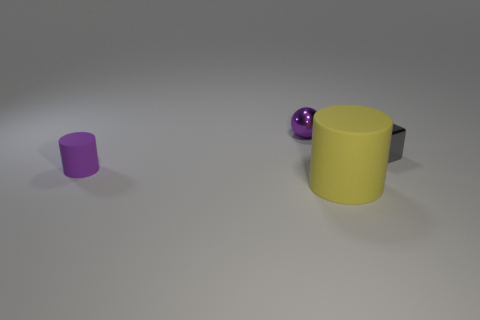What shape is the shiny object that is the same color as the tiny rubber cylinder?
Provide a short and direct response. Sphere. What is the size of the cylinder that is to the right of the ball that is on the left side of the large matte thing?
Provide a short and direct response. Large. There is a metallic ball that is the same color as the tiny rubber object; what size is it?
Give a very brief answer. Small. Is the gray thing the same size as the yellow thing?
Keep it short and to the point. No. What number of other things are there of the same shape as the purple shiny object?
Offer a very short reply. 0. What material is the tiny thing that is to the right of the metallic object that is on the left side of the yellow cylinder?
Your answer should be compact. Metal. There is a big yellow cylinder; are there any matte cylinders to the left of it?
Your answer should be compact. Yes. There is a purple metal ball; is its size the same as the thing left of the tiny ball?
Offer a terse response. Yes. There is another object that is the same shape as the big yellow object; what is its size?
Your answer should be very brief. Small. There is a shiny object behind the tiny cube; is it the same size as the yellow cylinder in front of the block?
Your answer should be very brief. No. 